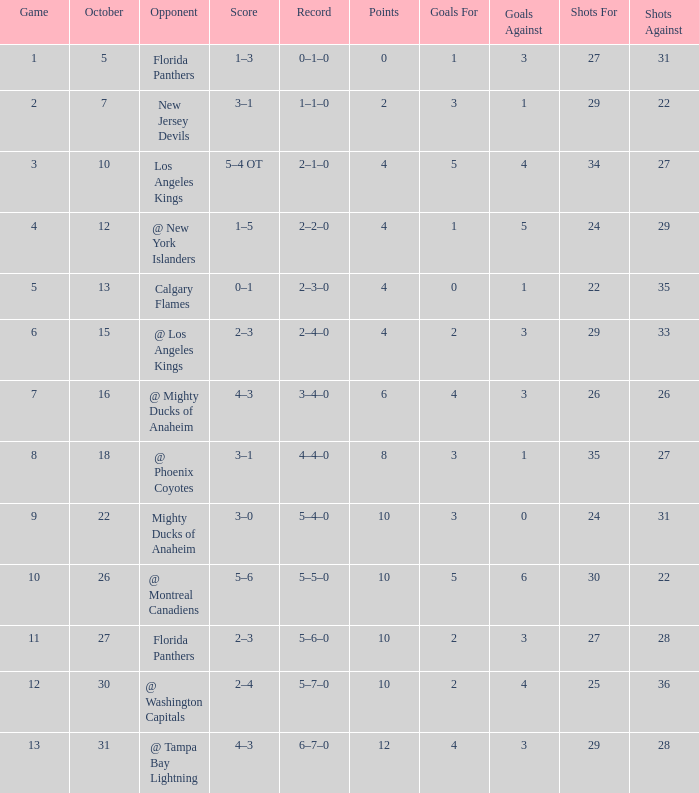What team has a score of 11 5–6–0. 